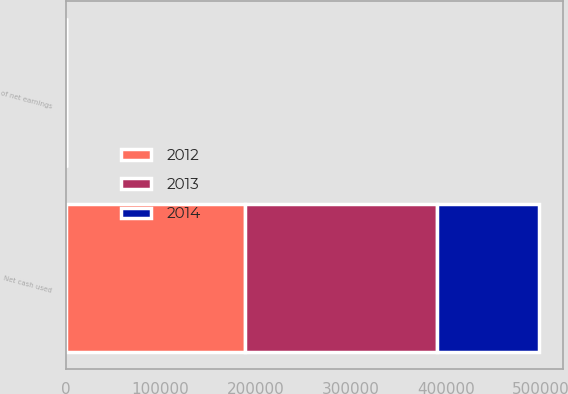Convert chart. <chart><loc_0><loc_0><loc_500><loc_500><stacked_bar_chart><ecel><fcel>Net cash used<fcel>of net earnings<nl><fcel>2012<fcel>188781<fcel>38.2<nl><fcel>2013<fcel>201792<fcel>45<nl><fcel>2014<fcel>107204<fcel>25.5<nl></chart> 